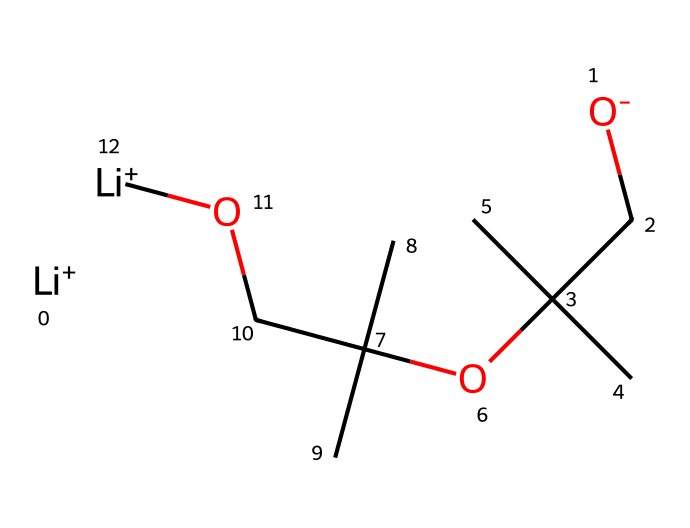What is the total number of carbon atoms in the structure? By examining the SMILES representation, we count the 'C' symbols, which represent carbon atoms. There are 8 'C' symbols present in the structure.
Answer: 8 How many lithium ions are present in this chemical? The SMILES representation includes two occurrences of '[Li+]', indicating the presence of two lithium ions in the structure.
Answer: 2 What type of bond connects the lithium ion to the oxygen atom? The connection between the lithium ions and the oxygen atoms in this structure involves an ionic bond, due to the charge difference between the positively charged lithium ions and the negatively charged oxygen atoms.
Answer: ionic Does this chemical have geometric isomers? The structure displays a lack of double bonds between carbon atoms and does not contain any distinguishing features (like different substituents) that can facilitate geometric isomerism. Therefore, it cannot have geometric isomers.
Answer: no What is the longest carbon chain in the structure? Analyzing the carbon atoms, the longest continuous chain consists of four carbon atoms (C-C-C-C), indicating the presence of a butyl group in the structure.
Answer: butyl What type of stereoisomers are possible with this polymer structure? This specific chemical structure does not have geometric isomers due to the absence of double bonds, but it could potentially exhibit stereoisomerism in other forms (like cis/trans) if applicable features were present.
Answer: none What functional group is present in this compound? The structure contains ether linkages as indicated by the 'OC' segments, which classify the compound as having ether functional groups.
Answer: ether 